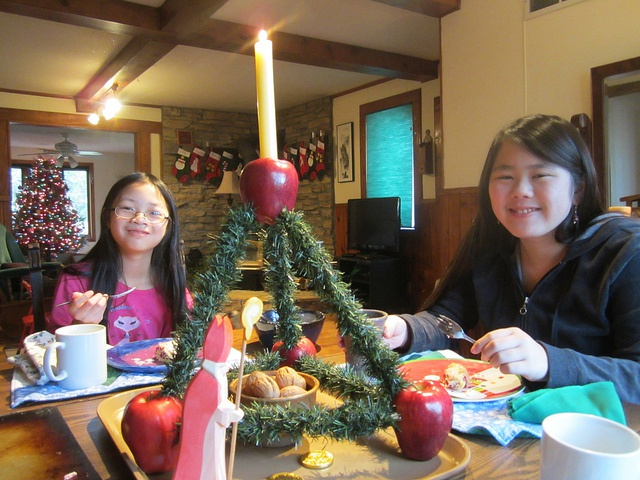Describe the objects in this image and their specific colors. I can see people in black, brown, gray, and lavender tones, people in black, gray, lightpink, and brown tones, cup in black, white, lightblue, and darkgray tones, dining table in black, tan, orange, and darkgray tones, and apple in black, maroon, brown, salmon, and red tones in this image. 